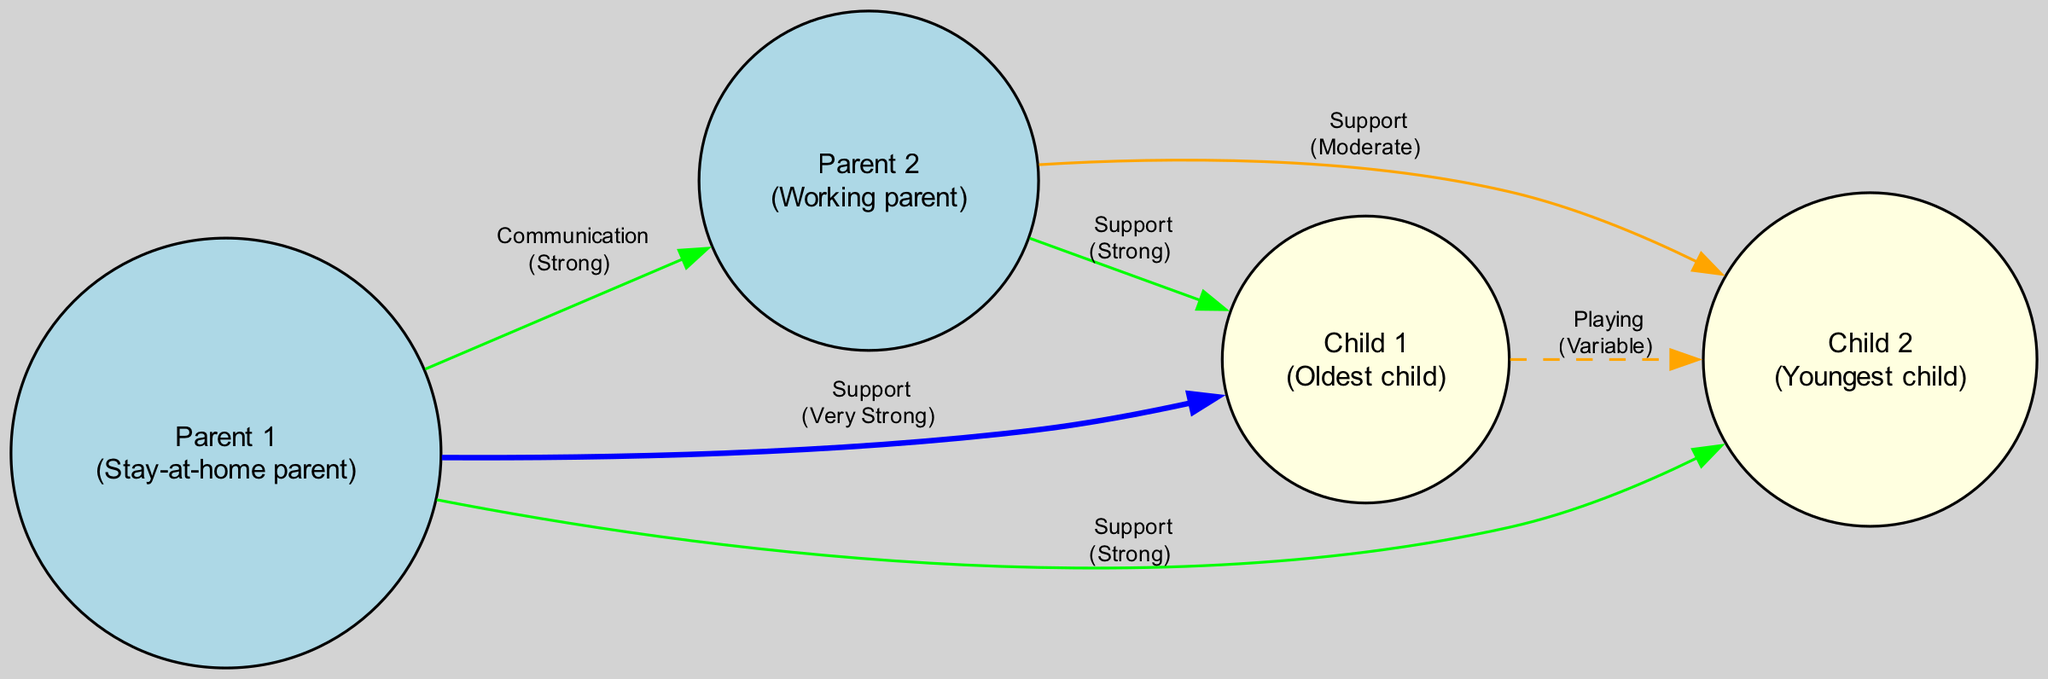What is the role of Child 1? The diagram lists each family member along with their role. Child 1 is identified as the "Oldest child."
Answer: Oldest child How many nodes are in the diagram? The diagram contains nodes for each family member, which are Parent 1, Parent 2, Child 1, and Child 2, totaling four nodes.
Answer: 4 What type of interaction exists between Parent 1 and Parent 2? The diagram specifies the type of interaction through edges connecting nodes. There is a "Communication" interaction between Parent 1 and Parent 2.
Answer: Communication Which family member has the strongest support relationship? The relationships are colored and labeled in the diagram, indicating their strength. Parent 1 has a "Very Strong" support relationship with Child 1.
Answer: Parent 1 How many edges are connected to Child 2? Analyzing the connections, Child 2 has three edges connecting it to other nodes: one to Parent 1, one to Parent 2, and one to Child 1.
Answer: 3 What is the strength of the interaction between Child 1 and Child 2? Looking at the edge that connects Child 1 and Child 2, it shows a "Variable" interaction strength.
Answer: Variable How many total relationships are represented in the diagram? By counting the edges listed in the diagram, there are a total of five relationships displayed.
Answer: 5 Which interaction is labeled with "Moderate" strength? The interaction from Parent 2 to Child 2 is labeled with "Moderate" strength according to the edge information in the diagram.
Answer: Moderate What color represents a Very Strong relationship in the diagram? The edges indicating a Very Strong relationship use the color green as specified in the diagram.
Answer: Green 